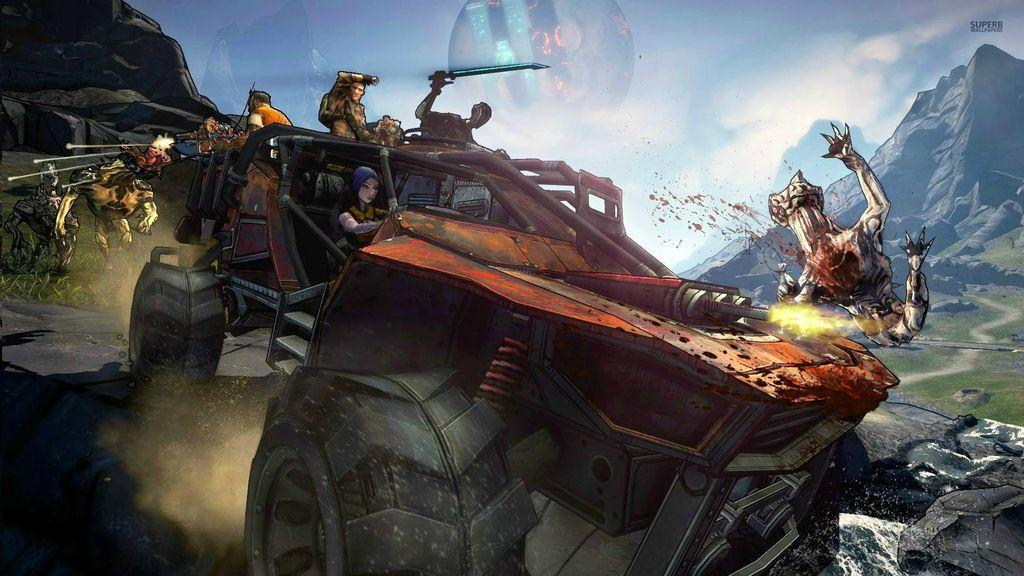What type of characters are in the image? There are cartoon characters in the image. What else can be seen in the image besides the cartoon characters? There is a vehicle present in the image. What type of landscape is visible in the image? There are mountains visible in the image. Where is the market located in the image? There is no market present in the image. What level of experience does the bell have in the image? There is no bell present in the image. 